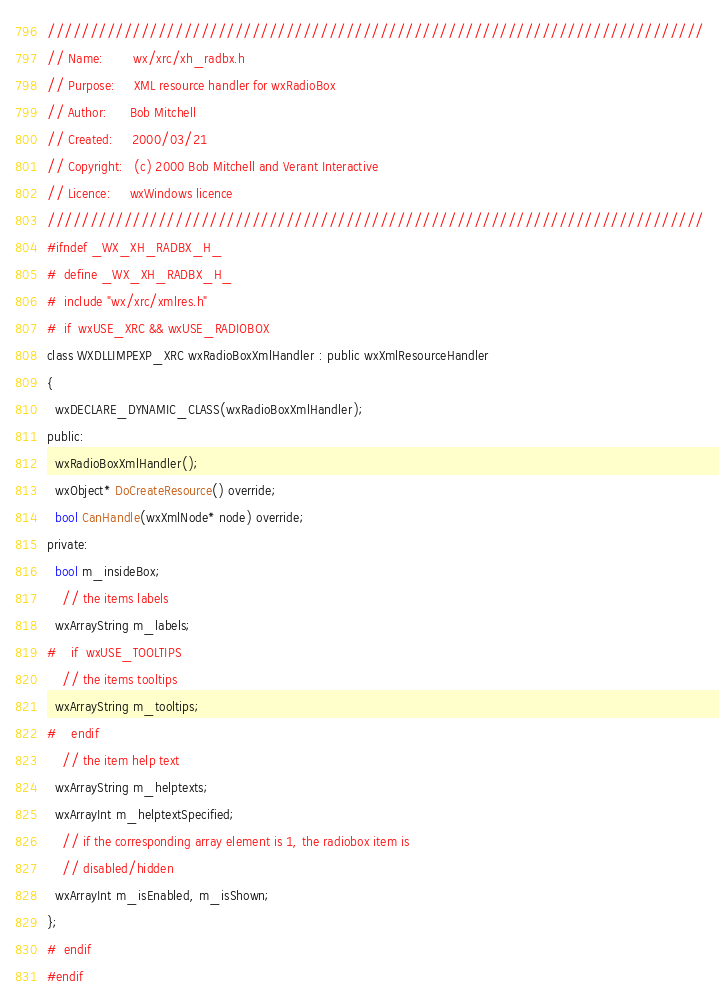Convert code to text. <code><loc_0><loc_0><loc_500><loc_500><_C_>/////////////////////////////////////////////////////////////////////////////
// Name:        wx/xrc/xh_radbx.h
// Purpose:     XML resource handler for wxRadioBox
// Author:      Bob Mitchell
// Created:     2000/03/21
// Copyright:   (c) 2000 Bob Mitchell and Verant Interactive
// Licence:     wxWindows licence
/////////////////////////////////////////////////////////////////////////////
#ifndef _WX_XH_RADBX_H_
#  define _WX_XH_RADBX_H_
#  include "wx/xrc/xmlres.h"
#  if  wxUSE_XRC && wxUSE_RADIOBOX
class WXDLLIMPEXP_XRC wxRadioBoxXmlHandler : public wxXmlResourceHandler
{
  wxDECLARE_DYNAMIC_CLASS(wxRadioBoxXmlHandler);
public:
  wxRadioBoxXmlHandler();
  wxObject* DoCreateResource() override;
  bool CanHandle(wxXmlNode* node) override;
private:
  bool m_insideBox;
    // the items labels
  wxArrayString m_labels;
#    if  wxUSE_TOOLTIPS
    // the items tooltips
  wxArrayString m_tooltips;
#    endif
    // the item help text
  wxArrayString m_helptexts;
  wxArrayInt m_helptextSpecified;
    // if the corresponding array element is 1, the radiobox item is
    // disabled/hidden
  wxArrayInt m_isEnabled, m_isShown;
};
#  endif
#endif
</code> 